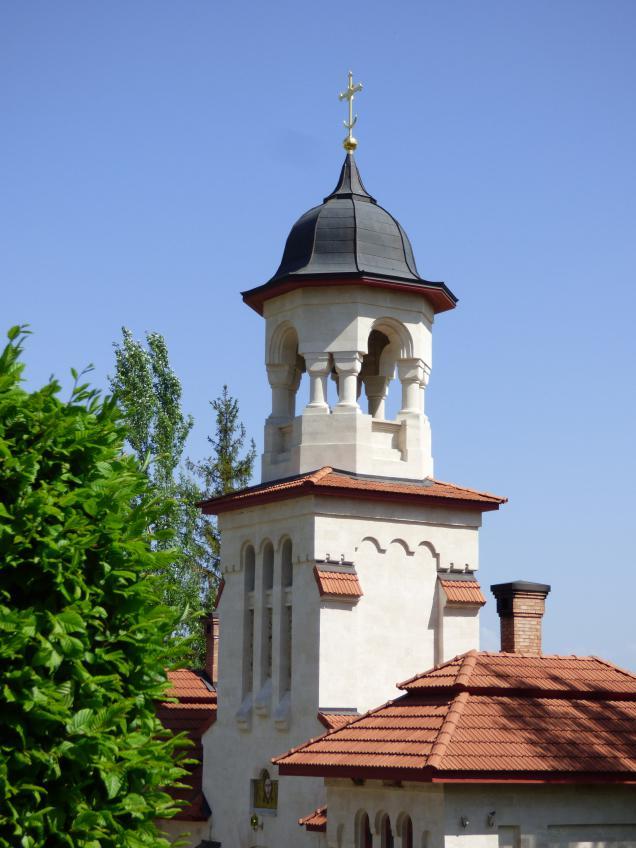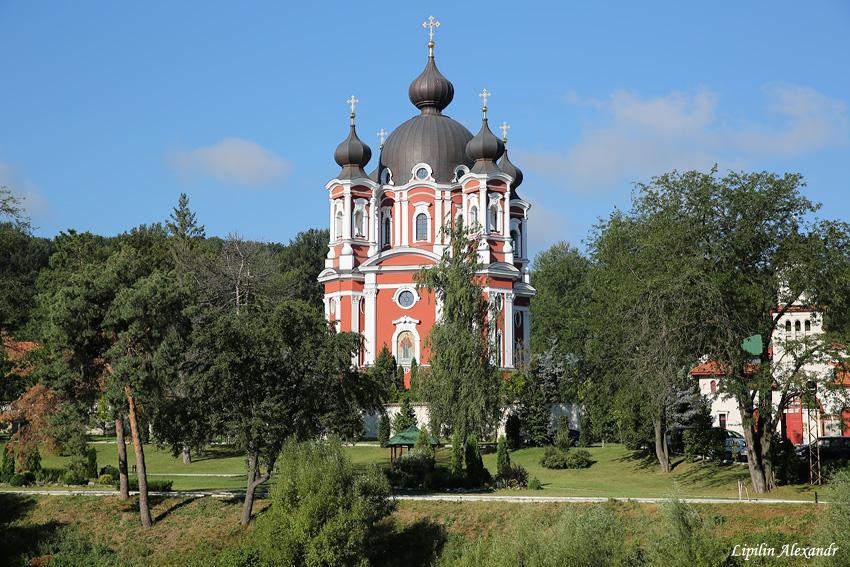The first image is the image on the left, the second image is the image on the right. Given the left and right images, does the statement "One image shows a building topped with multiple dark gray onion-shapes with crosses on top." hold true? Answer yes or no. Yes. The first image is the image on the left, the second image is the image on the right. Examine the images to the left and right. Is the description "In one image, a large building is red with white trim and a black decorative rooftop." accurate? Answer yes or no. Yes. 